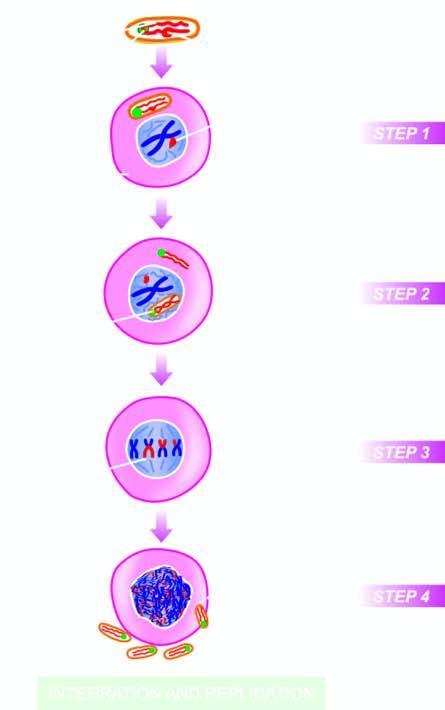what fuses with the plasma membrane of the host cell?
Answer the question using a single word or phrase. The viral envelope 